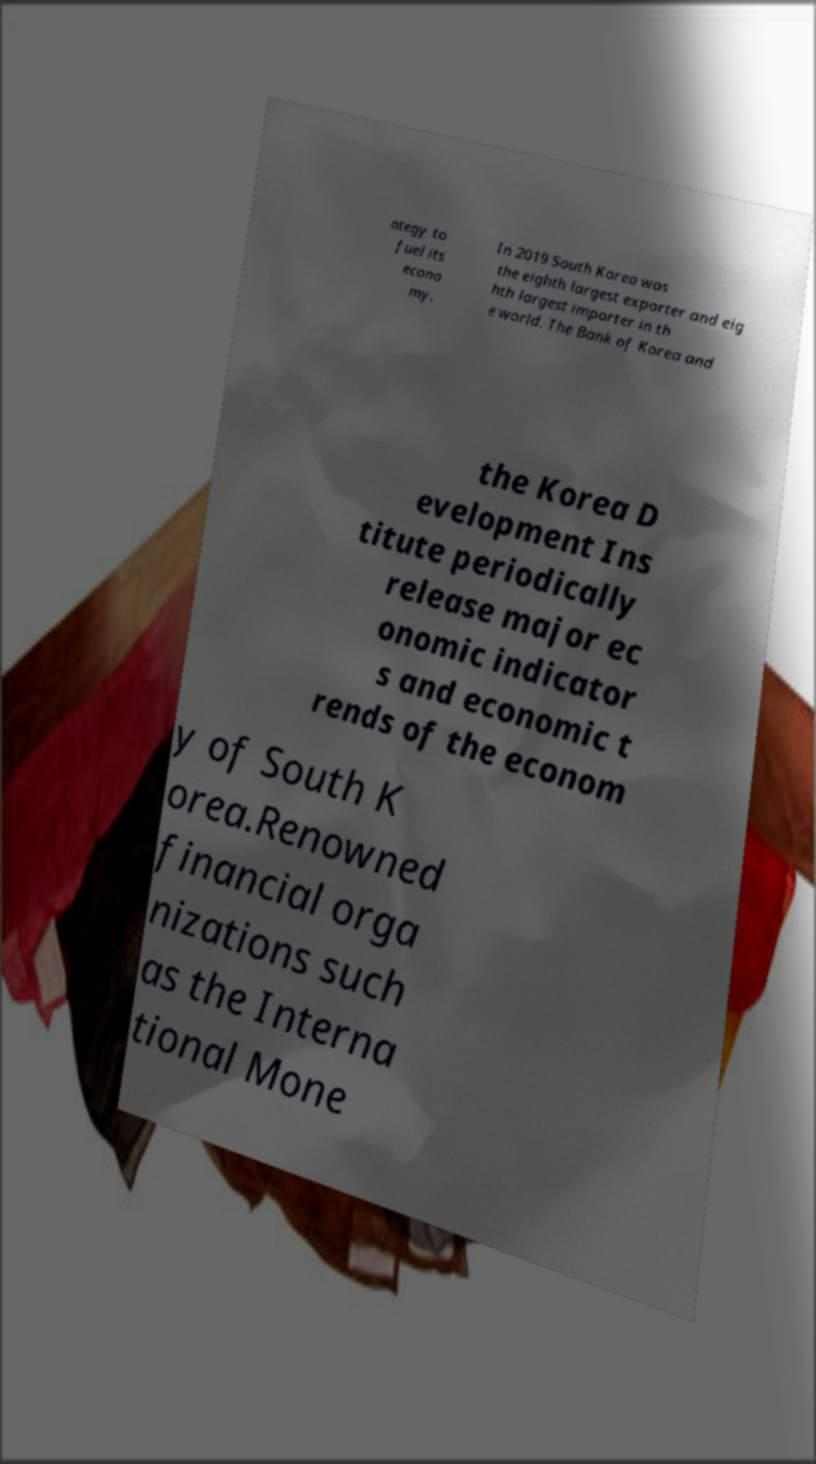Could you extract and type out the text from this image? ategy to fuel its econo my. In 2019 South Korea was the eighth largest exporter and eig hth largest importer in th e world. The Bank of Korea and the Korea D evelopment Ins titute periodically release major ec onomic indicator s and economic t rends of the econom y of South K orea.Renowned financial orga nizations such as the Interna tional Mone 